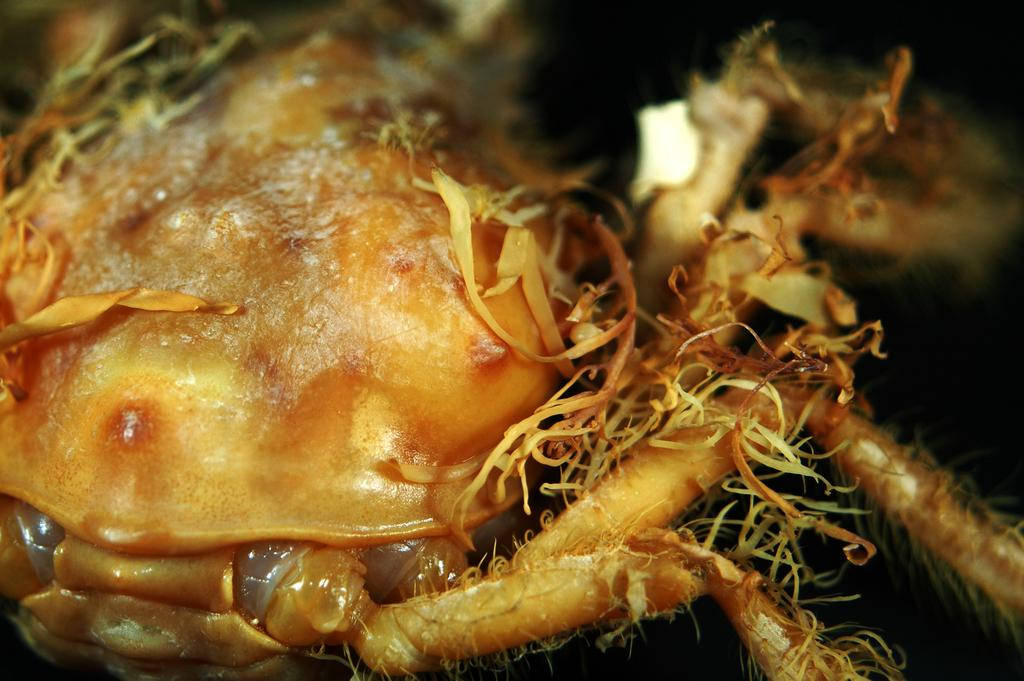What type of objects can be seen in the image? There are food items present in the image. What type of band can be seen playing in the image? There is no band present in the image; it only features food items. What kind of yak is visible in the image? There is no yak present in the image; it only features food items. 